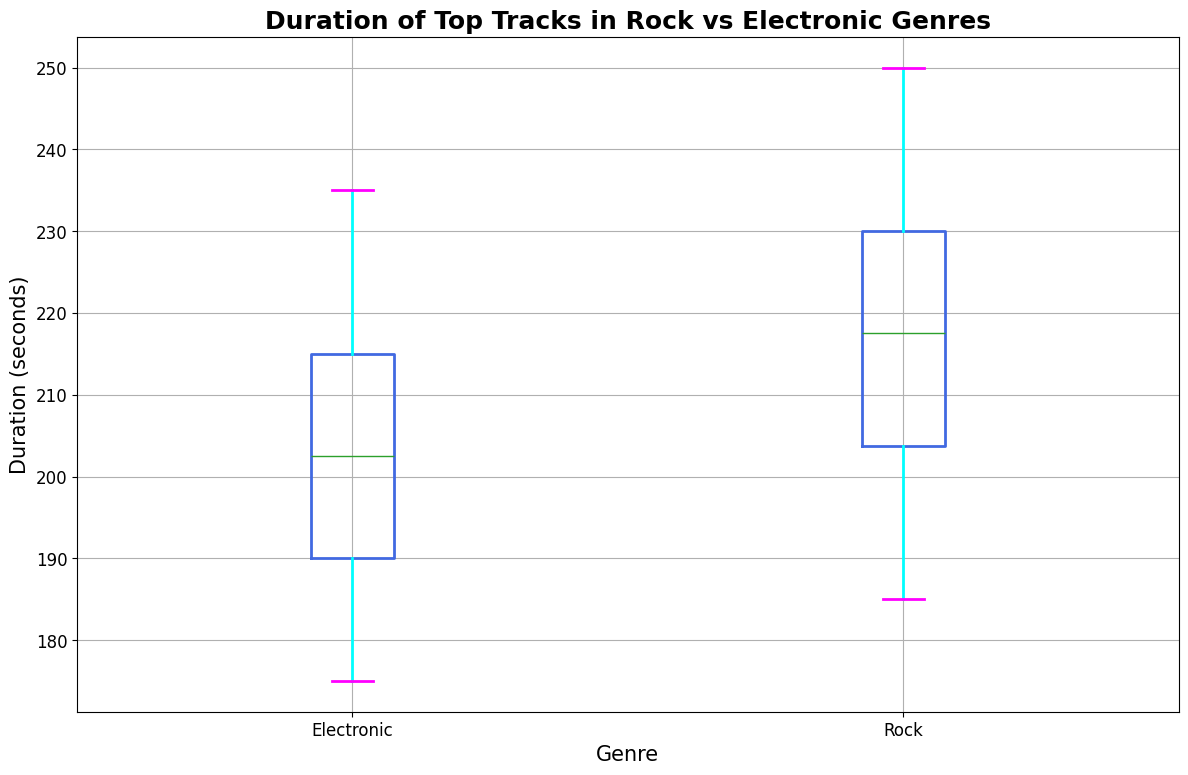What's the median duration for Rock tracks? To determine the median, we need to identify the middle value in the sorted list of Rock track durations. Since there are 20 Rock track durations, the median will be the average of the 10th and 11th values. The sorted list is: 185, 190, 195, 200, 200, 200, 205, 205, 210, 210, 215, 220, 220, 225, 230, 230, 230, 240, 245, 250. The 10th value is 210 and the 11th value is 215. Thus, the median is (210 + 215) / 2 = 212.5.
Answer: 212.5 Which genre has a longer interquartile range (IQR)? The IQR is the difference between the 75th percentile (Q3) and the 25th percentile (Q1). For Rock, Q3 is ~230 and Q1 is ~200, making the IQR 230 - 200 = 30. For Electronic, Q3 is ~215 and Q1 is ~190, making the IQR 215 - 190 = 25. Therefore, Rock has a longer IQR.
Answer: Rock What is the maximum duration of Electronic tracks? By looking at the top whisker or the highest value in the Electronic genre box plot, we can identify the maximum duration. The maximum duration for Electronic tracks is 235 seconds.
Answer: 235 How does the median duration of Rock tracks compare to the median duration of Electronic tracks? The median duration for Rock tracks is 212.5 seconds, while for Electronic tracks, it is ~200 seconds (directly from the median line in the box plot). Therefore, the median duration for Rock tracks is higher than that for Electronic tracks.
Answer: Rock's median is higher What's the range of durations for Rock tracks? The range is calculated by subtracting the minimum duration from the maximum duration in the Rock genre. The smallest duration is 185 seconds and the largest duration is 250 seconds. So, the range is 250 - 185 = 65 seconds.
Answer: 65 Which genre has more outliers, and what are their values? Outliers are generally marked by points outside the whiskers in a box plot. By observing the plot, Rock has no outliers as there are no points outside the whiskers. Electronic also has no outliers. Therefore, neither genre has any outliers in this dataset.
Answer: Neither What is the lower quartile (Q1) value for the Electronic genre? To determine Q1 for Electronic, we look at the bottom of the box for the Electronic genre. The lower quartile for Electronic tracks is approximately 190 seconds.
Answer: 190 Are there any Electronic tracks with durations longer than the longest Rock track? The longest Rock track duration is 250 seconds, while the maximum duration for Electronic tracks is 235 seconds. Thus, no Electronic track durations exceed the longest Rock track duration.
Answer: No How do the box colors of both genres visually appear? The box itself is colored in royal blue, the caps are colored in magenta, the whiskers are cyan, and any outliers are in green. This consistent color scheme allows for easy visual comparison across genres.
Answer: Royal blue, magenta, cyan, green How do the mean durations of both genres compare, based on visual cues? While the box plot primarily provides median values, we can infer that the mean duration of Rock tracks is likely higher than Electronic tracks, given that the median and the overall spread (range and quartiles) are larger for Rock. Exact means aren’t shown, but the median and distribution suggest Rock tracks are typically longer.
Answer: Rock's mean is likely higher 